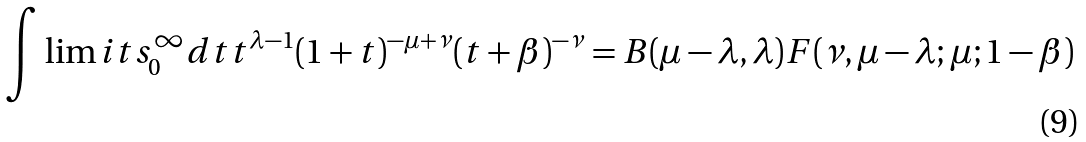<formula> <loc_0><loc_0><loc_500><loc_500>\int \lim i t s _ { 0 } ^ { \infty } d t t ^ { \lambda - 1 } ( 1 + t ) ^ { - \mu + \nu } ( t + \beta ) ^ { - \nu } = B ( \mu - \lambda , \lambda ) F ( \nu , \mu - \lambda ; \mu ; 1 - \beta )</formula> 